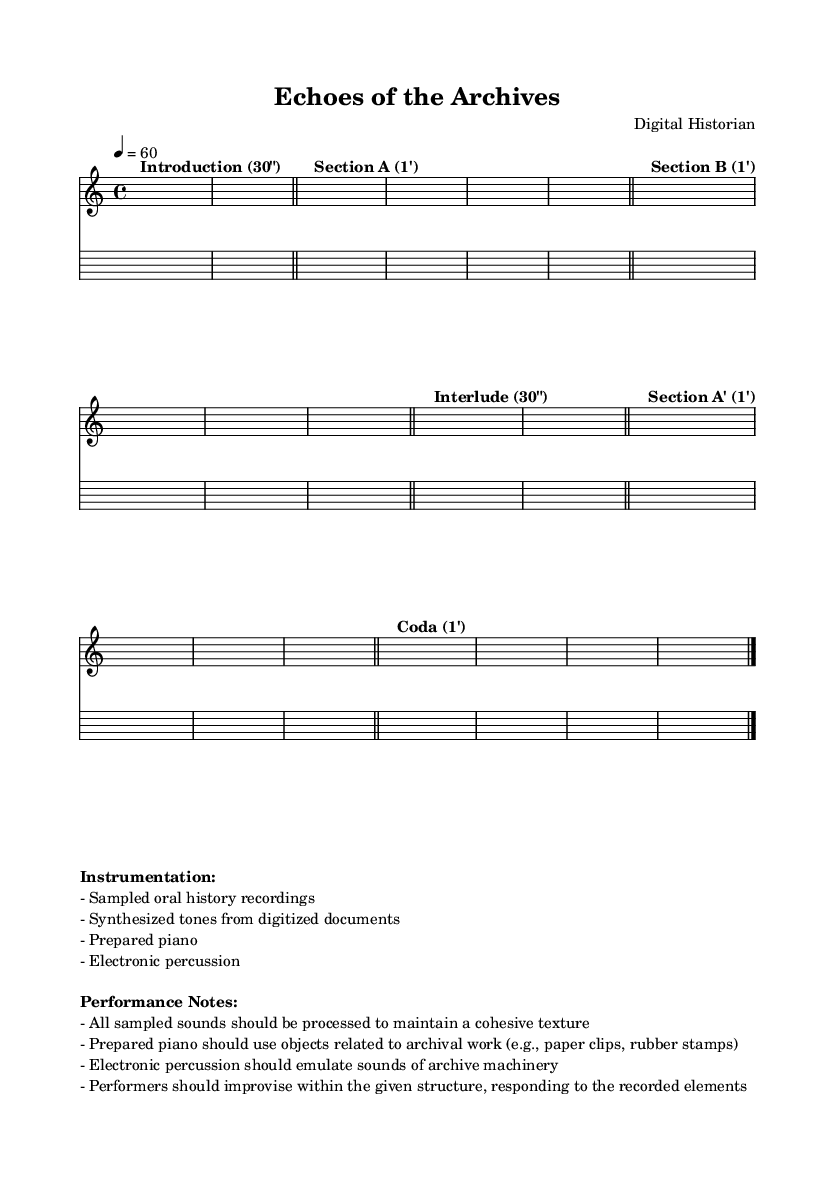What is the key signature of this music? The key signature is C major, which has no sharps or flats.
Answer: C major What is the time signature of the piece? The time signature is found at the beginning of the score and indicates measures of four beats.
Answer: 4/4 What is the tempo marking for this piece? The tempo marking is indicated at the start of the score, stating the speed of the piece.
Answer: 60 What is the duration of Section A? The duration for Section A is labeled in the score with the time duration written above the music.
Answer: 1' What instruments are being used in this composition? The instrumentation list is provided in the markup section and outlines all the sounds and instruments incorporated in the piece.
Answer: Sampled oral history recordings, synthesized tones, prepared piano, electronic percussion How many sections does the piece contain? By analyzing the structure written in the sheet music, each distinct part is labeled and counted to find the total sections.
Answer: 5 What unique materials are suggested for the prepared piano? The performance notes specify objects to be used with the prepared piano, indicating their connection to archival work.
Answer: Paper clips, rubber stamps 